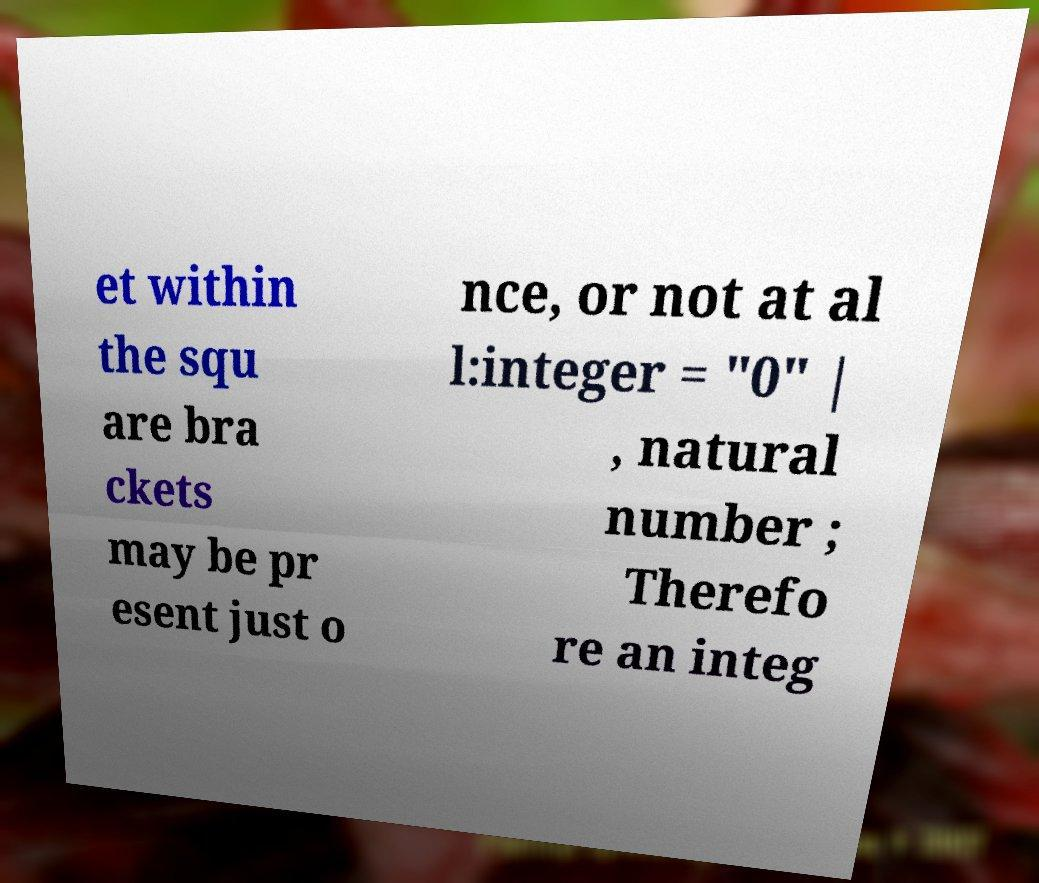Can you accurately transcribe the text from the provided image for me? et within the squ are bra ckets may be pr esent just o nce, or not at al l:integer = "0" | , natural number ; Therefo re an integ 